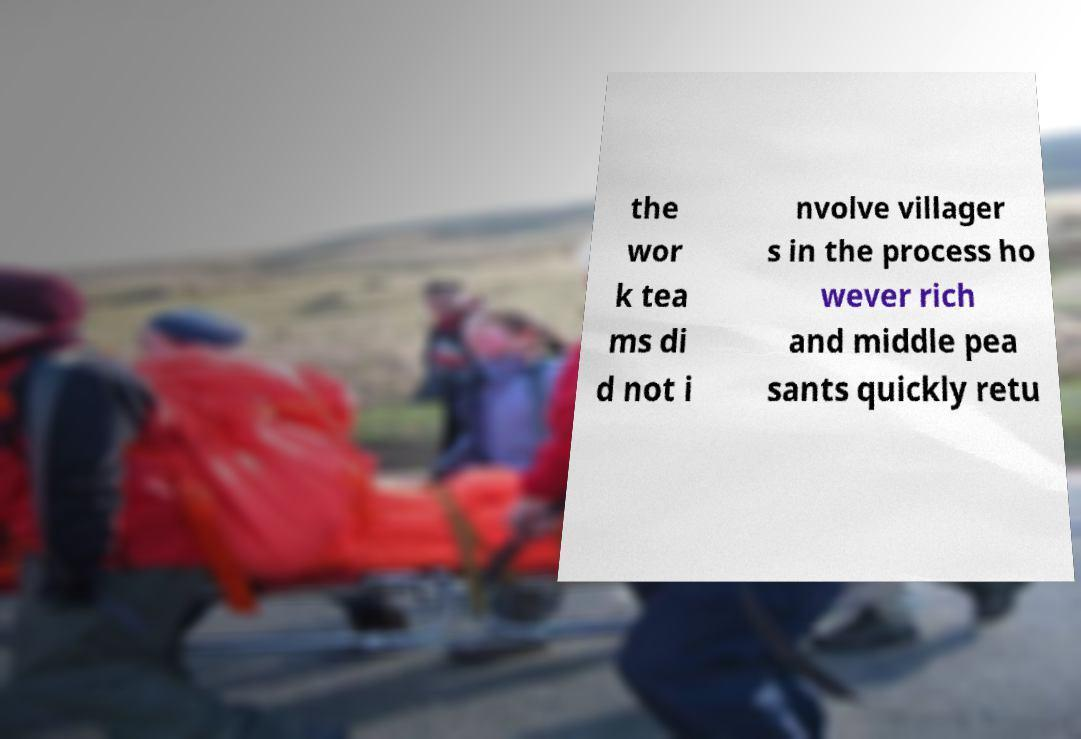What messages or text are displayed in this image? I need them in a readable, typed format. the wor k tea ms di d not i nvolve villager s in the process ho wever rich and middle pea sants quickly retu 